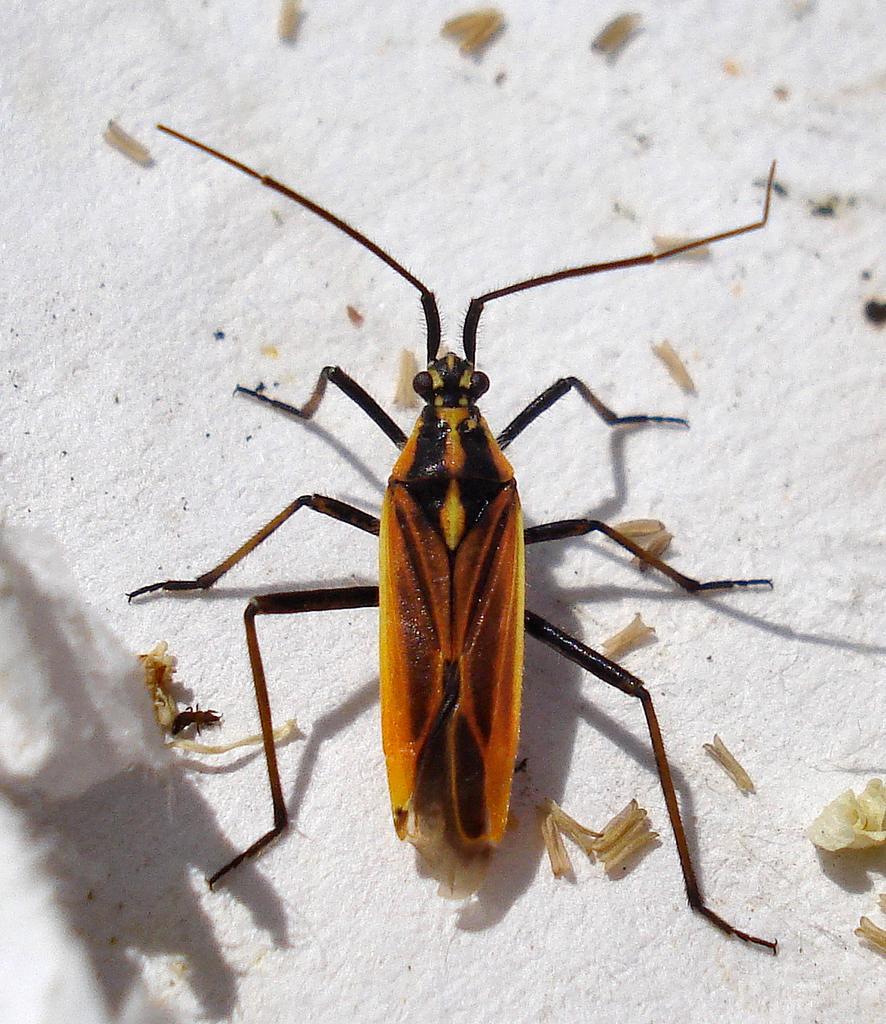Can you describe this image briefly? Here we can see an insect and waste particles on a platform. 